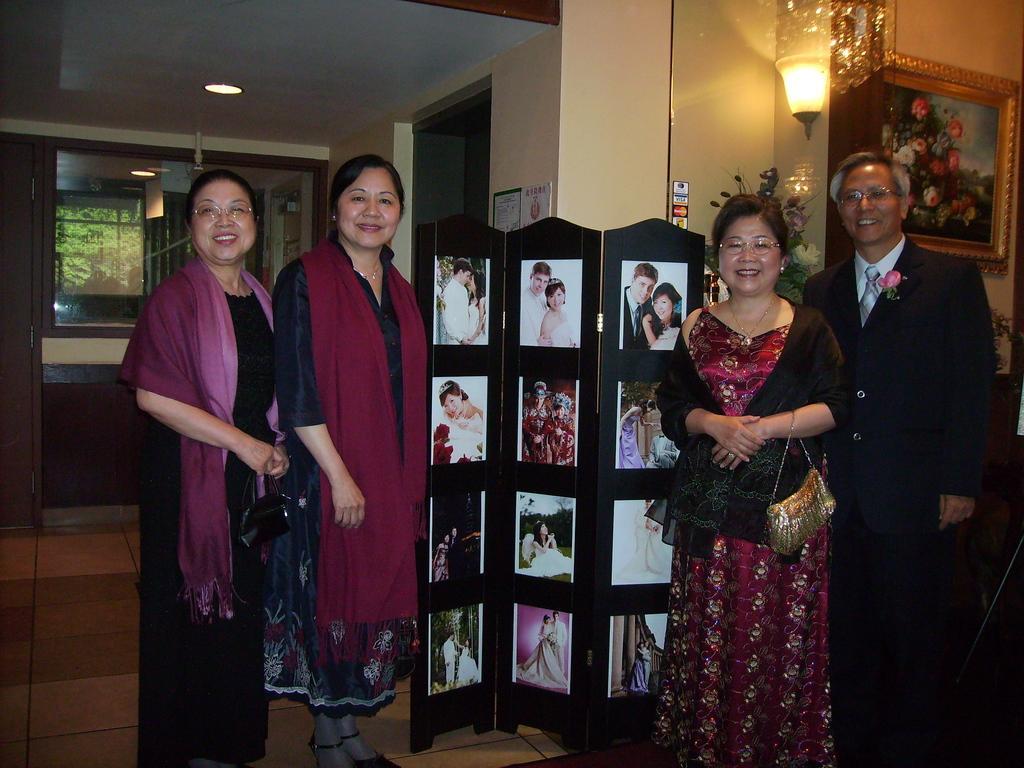Please provide a concise description of this image. On the left side, there are two women, smiling and standing. On the right side, there is a woman and a man, smiling and standing. In the background, there are photo frames and a light attached to a wall, there are flower vases, there are lights attached to a roof, there is a wall and a mirror. 